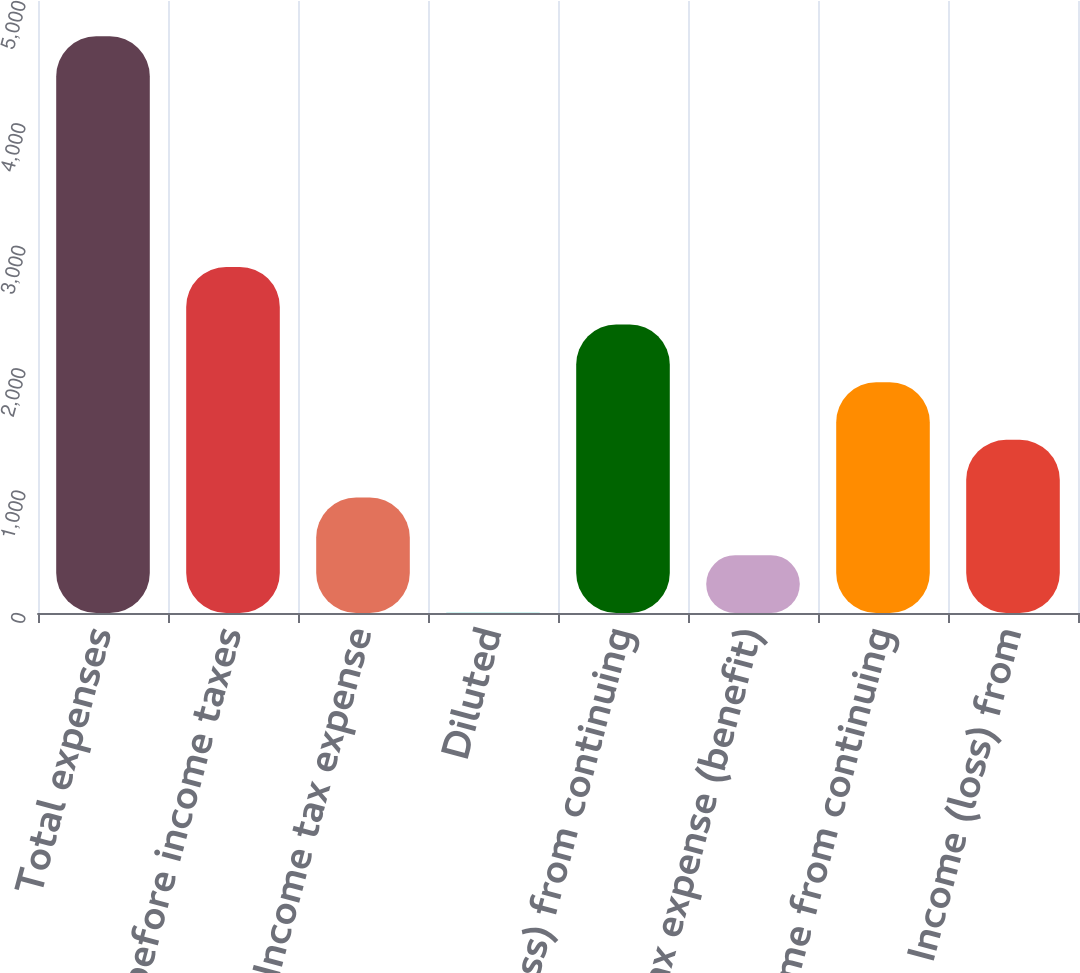<chart> <loc_0><loc_0><loc_500><loc_500><bar_chart><fcel>Total expenses<fcel>Income before income taxes<fcel>Income tax expense<fcel>Diluted<fcel>Income (loss) from continuing<fcel>Income tax expense (benefit)<fcel>Income from continuing<fcel>Income (loss) from<nl><fcel>4712<fcel>2827.77<fcel>943.53<fcel>1.41<fcel>2356.71<fcel>472.47<fcel>1885.65<fcel>1414.59<nl></chart> 